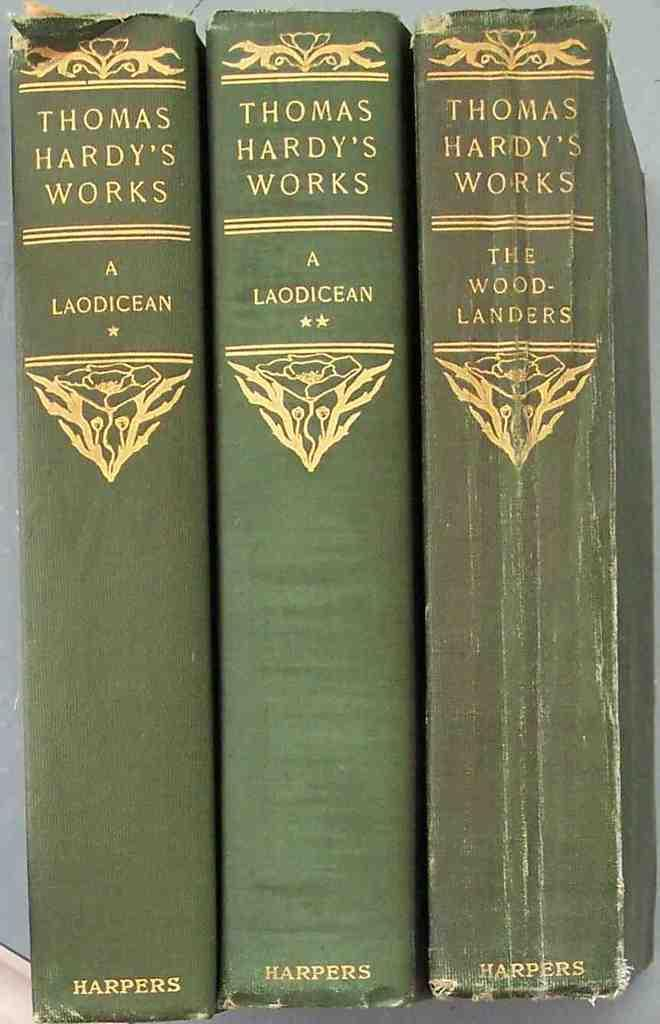Provide a one-sentence caption for the provided image. Three books of Thomas Hardy's work are lined up with the spines visible. 